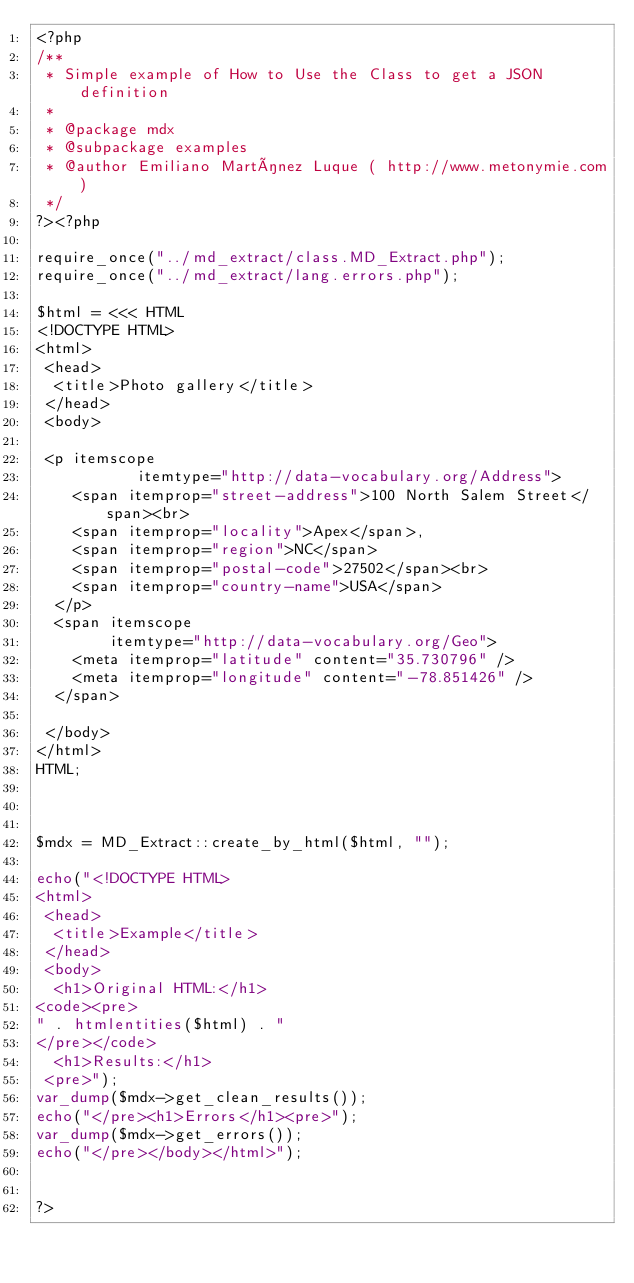Convert code to text. <code><loc_0><loc_0><loc_500><loc_500><_PHP_><?php
/**
 * Simple example of How to Use the Class to get a JSON definition
 * 
 * @package mdx
 * @subpackage examples
 * @author Emiliano Martínez Luque ( http://www.metonymie.com)
 */
?><?php 

require_once("../md_extract/class.MD_Extract.php");
require_once("../md_extract/lang.errors.php");

$html = <<< HTML
<!DOCTYPE HTML>
<html>
 <head>
  <title>Photo gallery</title>
 </head>
 <body>

 <p itemscope
           itemtype="http://data-vocabulary.org/Address">
    <span itemprop="street-address">100 North Salem Street</span><br>
    <span itemprop="locality">Apex</span>,
    <span itemprop="region">NC</span>
    <span itemprop="postal-code">27502</span><br>
    <span itemprop="country-name">USA</span>
  </p>
  <span itemscope
        itemtype="http://data-vocabulary.org/Geo">
    <meta itemprop="latitude" content="35.730796" />
    <meta itemprop="longitude" content="-78.851426" />
  </span>
  
 </body>
</html>
HTML;



$mdx = MD_Extract::create_by_html($html, "");

echo("<!DOCTYPE HTML>
<html>
 <head>
  <title>Example</title>
 </head>
 <body>
  <h1>Original HTML:</h1>
<code><pre>
" . htmlentities($html) . "
</pre></code>
  <h1>Results:</h1>
 <pre>");
var_dump($mdx->get_clean_results());
echo("</pre><h1>Errors</h1><pre>");
var_dump($mdx->get_errors());
echo("</pre></body></html>");


?></code> 